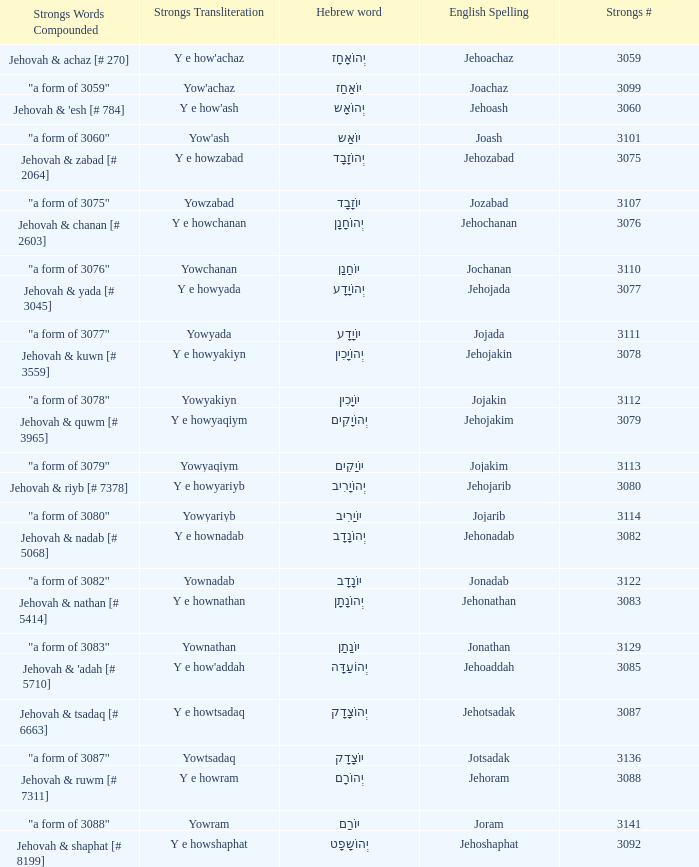What is the strongs words compounded when the english spelling is jonadab? "a form of 3082". 